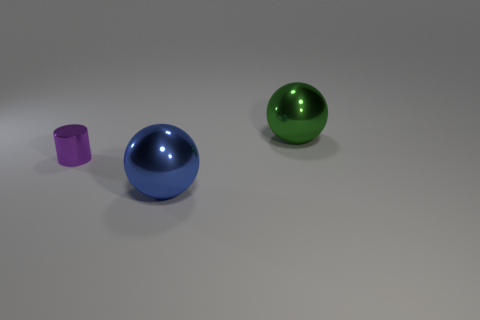Subtract all green balls. How many balls are left? 1 Add 1 big blue balls. How many objects exist? 4 Subtract 0 brown cylinders. How many objects are left? 3 Subtract all cylinders. How many objects are left? 2 Subtract all red cylinders. Subtract all purple balls. How many cylinders are left? 1 Subtract all green cylinders. How many green spheres are left? 1 Subtract all small purple things. Subtract all big objects. How many objects are left? 0 Add 3 large green things. How many large green things are left? 4 Add 2 tiny brown cylinders. How many tiny brown cylinders exist? 2 